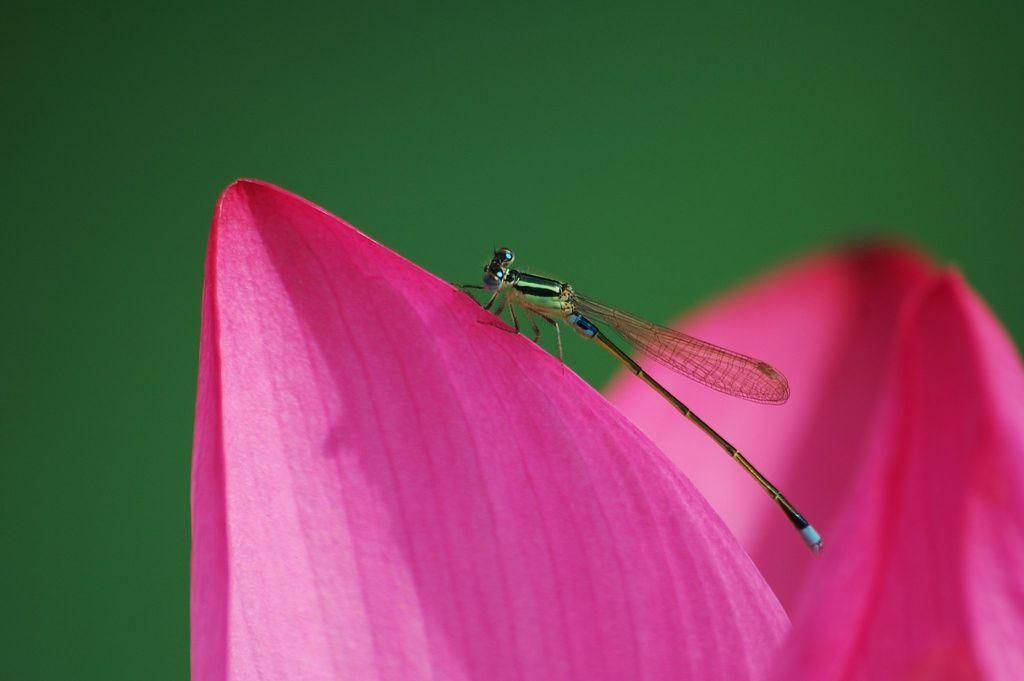What insect is present in the image? There is a dragonfly in the image. What is the dragonfly sitting on? The dragonfly is sitting on a pink flower. What color is the background of the image? The background of the image is green. Where is the seat located in the image? There is no seat present in the image. What type of pocket can be seen on the dragonfly in the image? Dragonflies do not have pockets, and there is no pocket visible in the image. 